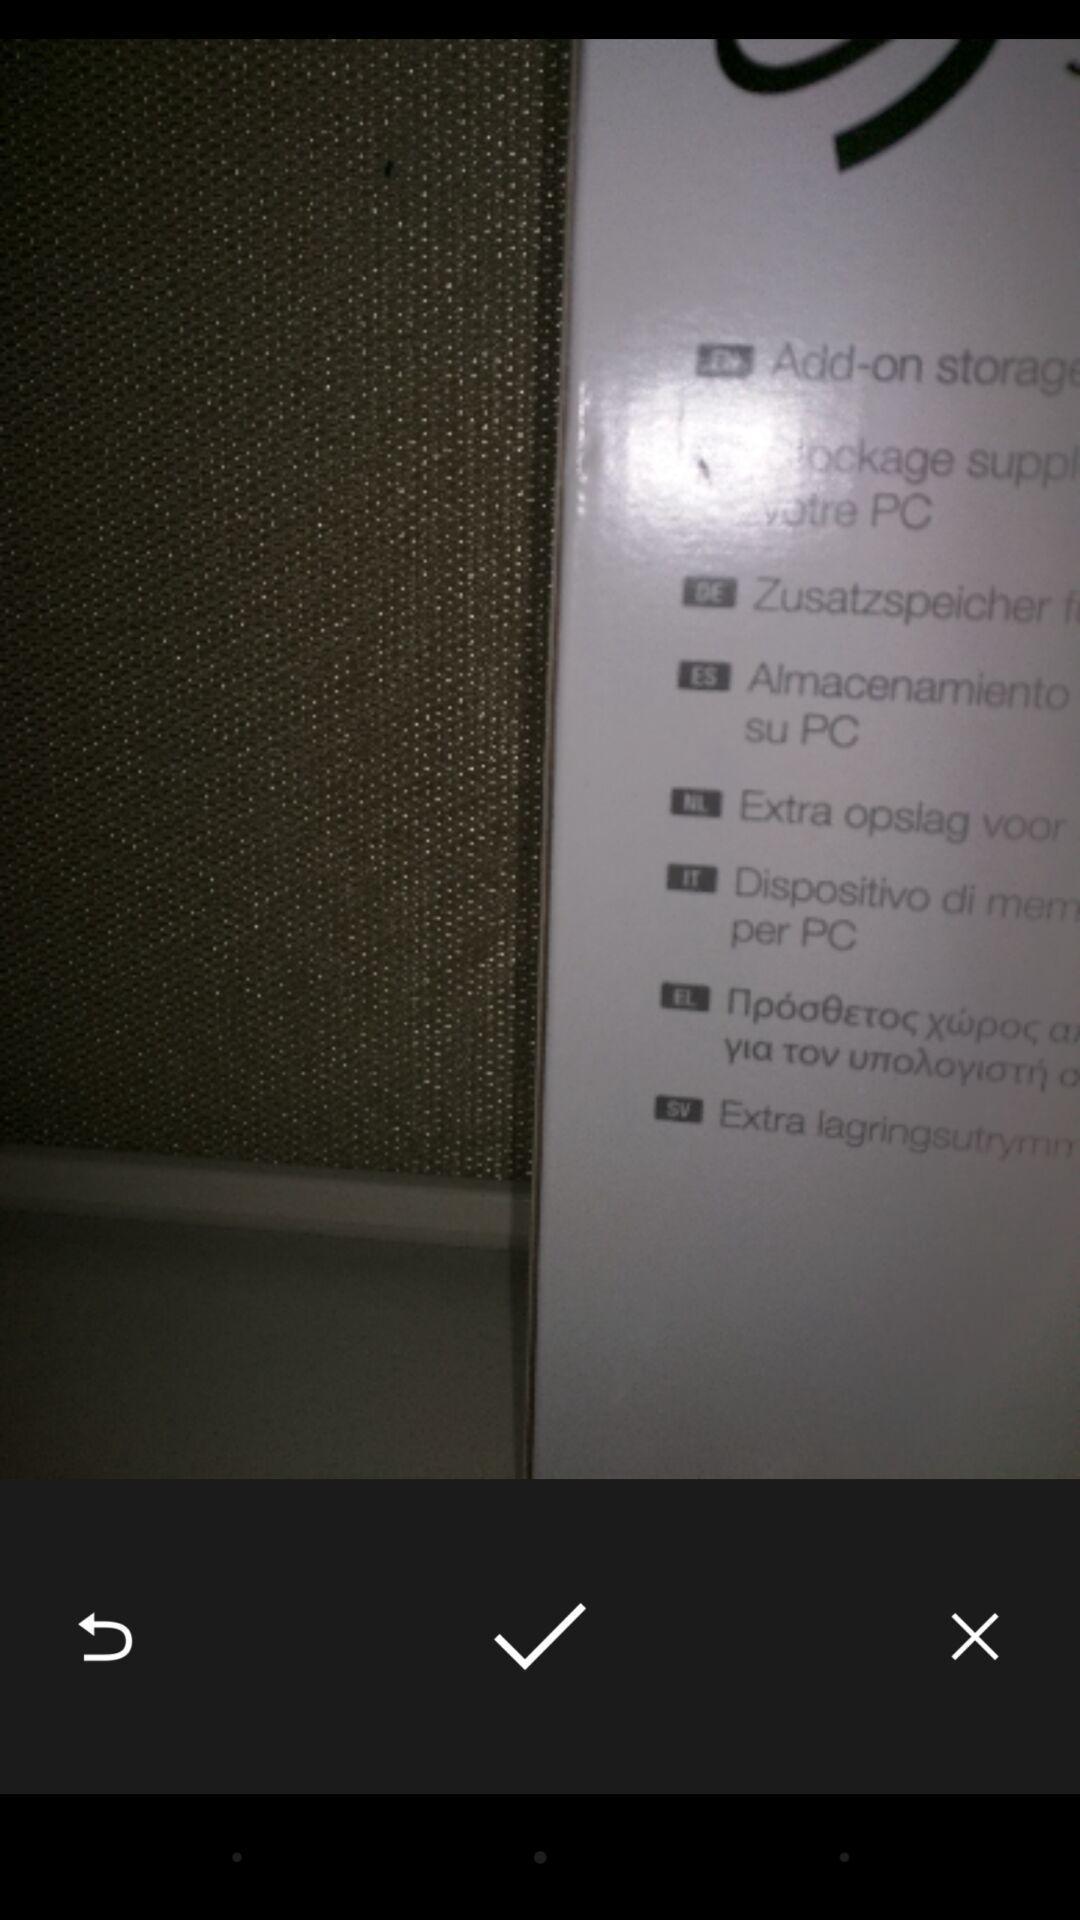Explain what's happening in this screen capture. Screen shows an image of a box. 